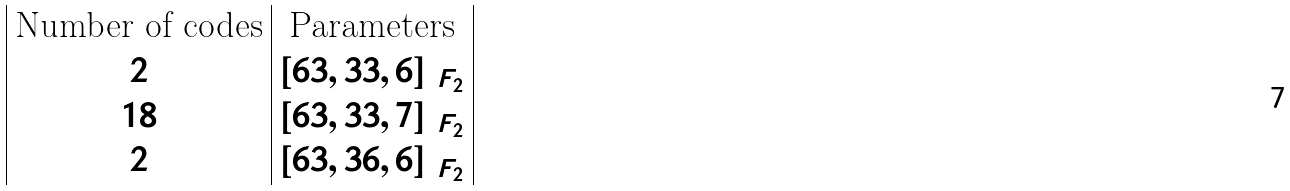Convert formula to latex. <formula><loc_0><loc_0><loc_500><loc_500>\begin{array} { | c | c | } \text {Number of codes} & \text {Parameters} \\ 2 & [ 6 3 , 3 3 , 6 ] _ { \ F _ { 2 } } \\ 1 8 & [ 6 3 , 3 3 , 7 ] _ { \ F _ { 2 } } \\ 2 & [ 6 3 , 3 6 , 6 ] _ { \ F _ { 2 } } \\ \end{array}</formula> 